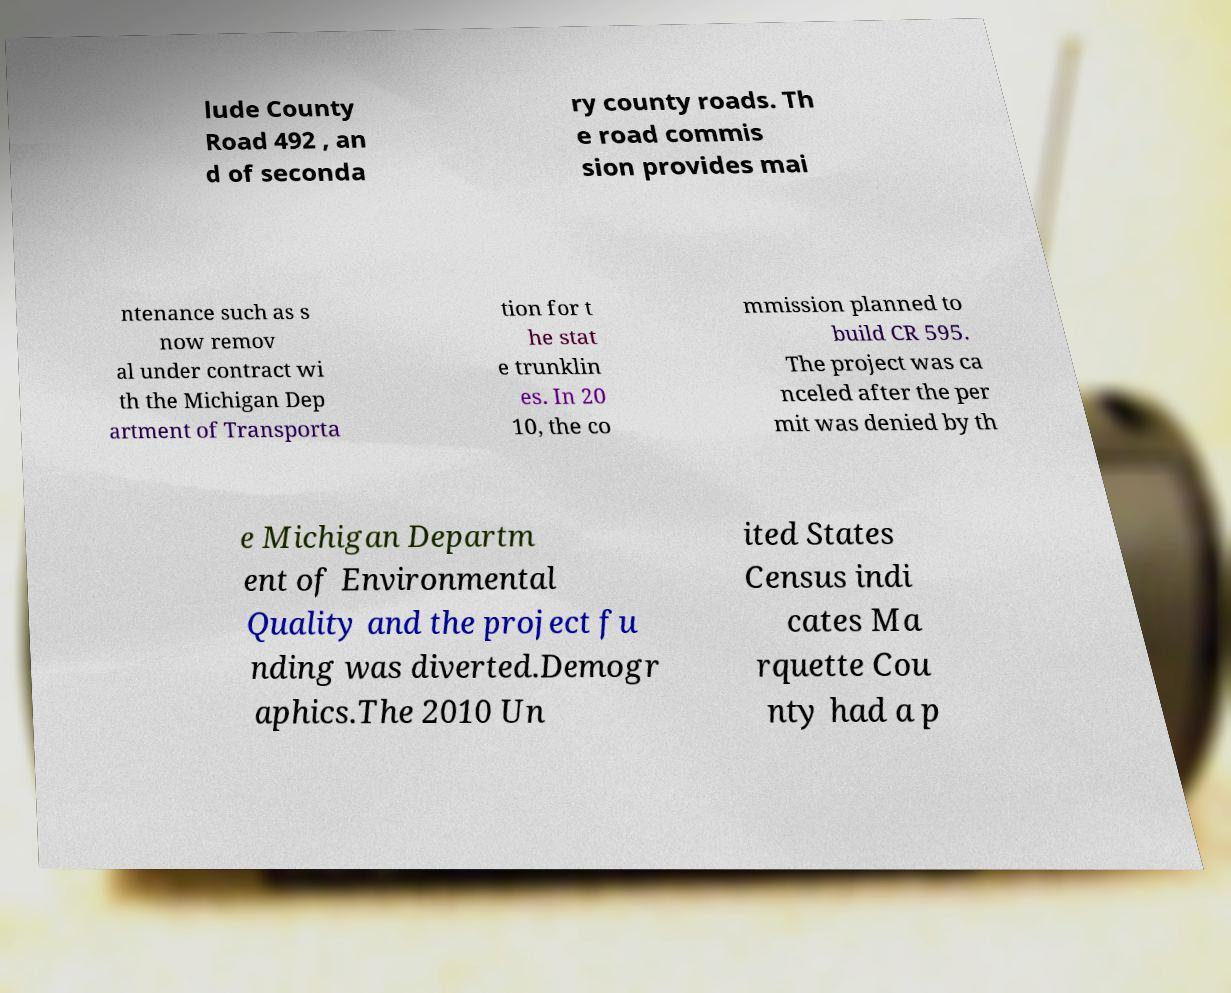What messages or text are displayed in this image? I need them in a readable, typed format. lude County Road 492 , an d of seconda ry county roads. Th e road commis sion provides mai ntenance such as s now remov al under contract wi th the Michigan Dep artment of Transporta tion for t he stat e trunklin es. In 20 10, the co mmission planned to build CR 595. The project was ca nceled after the per mit was denied by th e Michigan Departm ent of Environmental Quality and the project fu nding was diverted.Demogr aphics.The 2010 Un ited States Census indi cates Ma rquette Cou nty had a p 